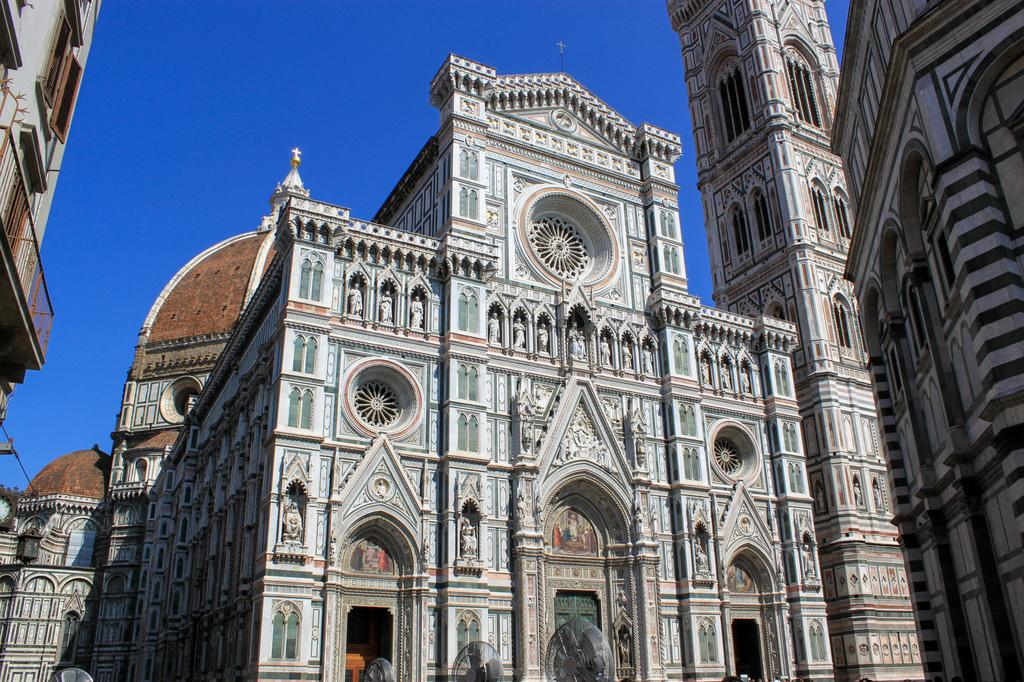What type of structures are present in the image? There are buildings in the image. What feature can be seen on the buildings? The buildings have windows. What part of the natural environment is visible in the image? The sky is visible in the image. What is the color of the sky in the image? The sky is blue in color. Can you see any hands holding a skate in the image? There are no hands or skates present in the image. What type of poison is being used by the buildings in the image? There is no poison mentioned or depicted in the image; it features buildings with windows and a blue sky. 